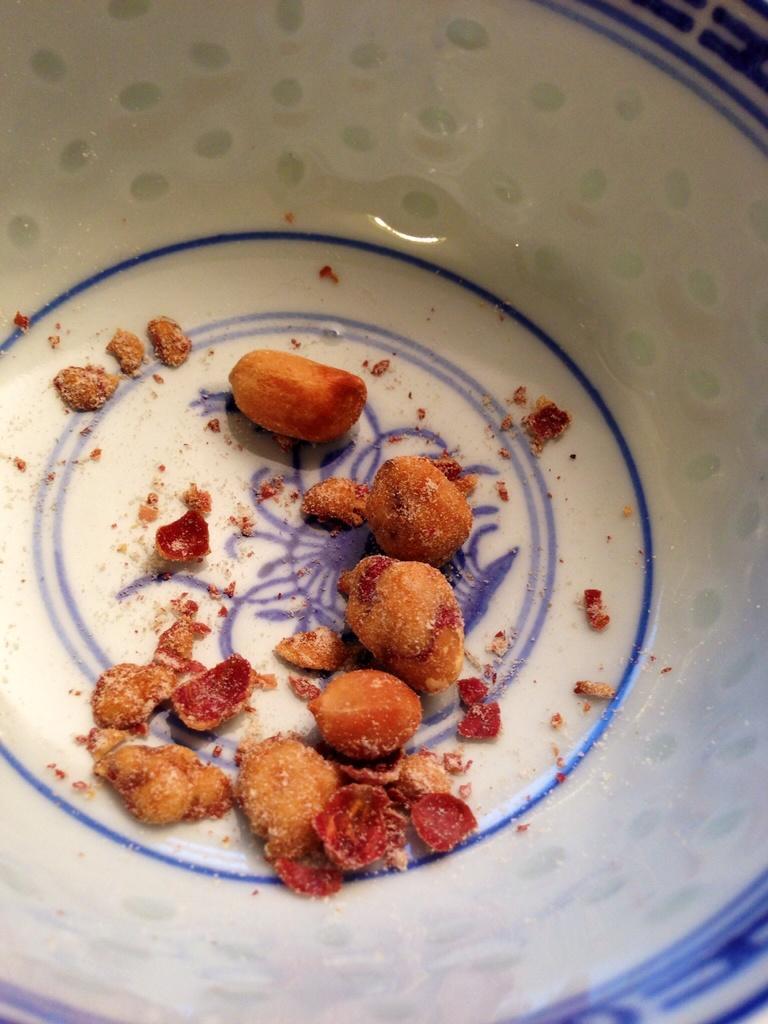How would you summarize this image in a sentence or two? This is a zoomed in picture. In the center there is a white color bowl containing some food item. 